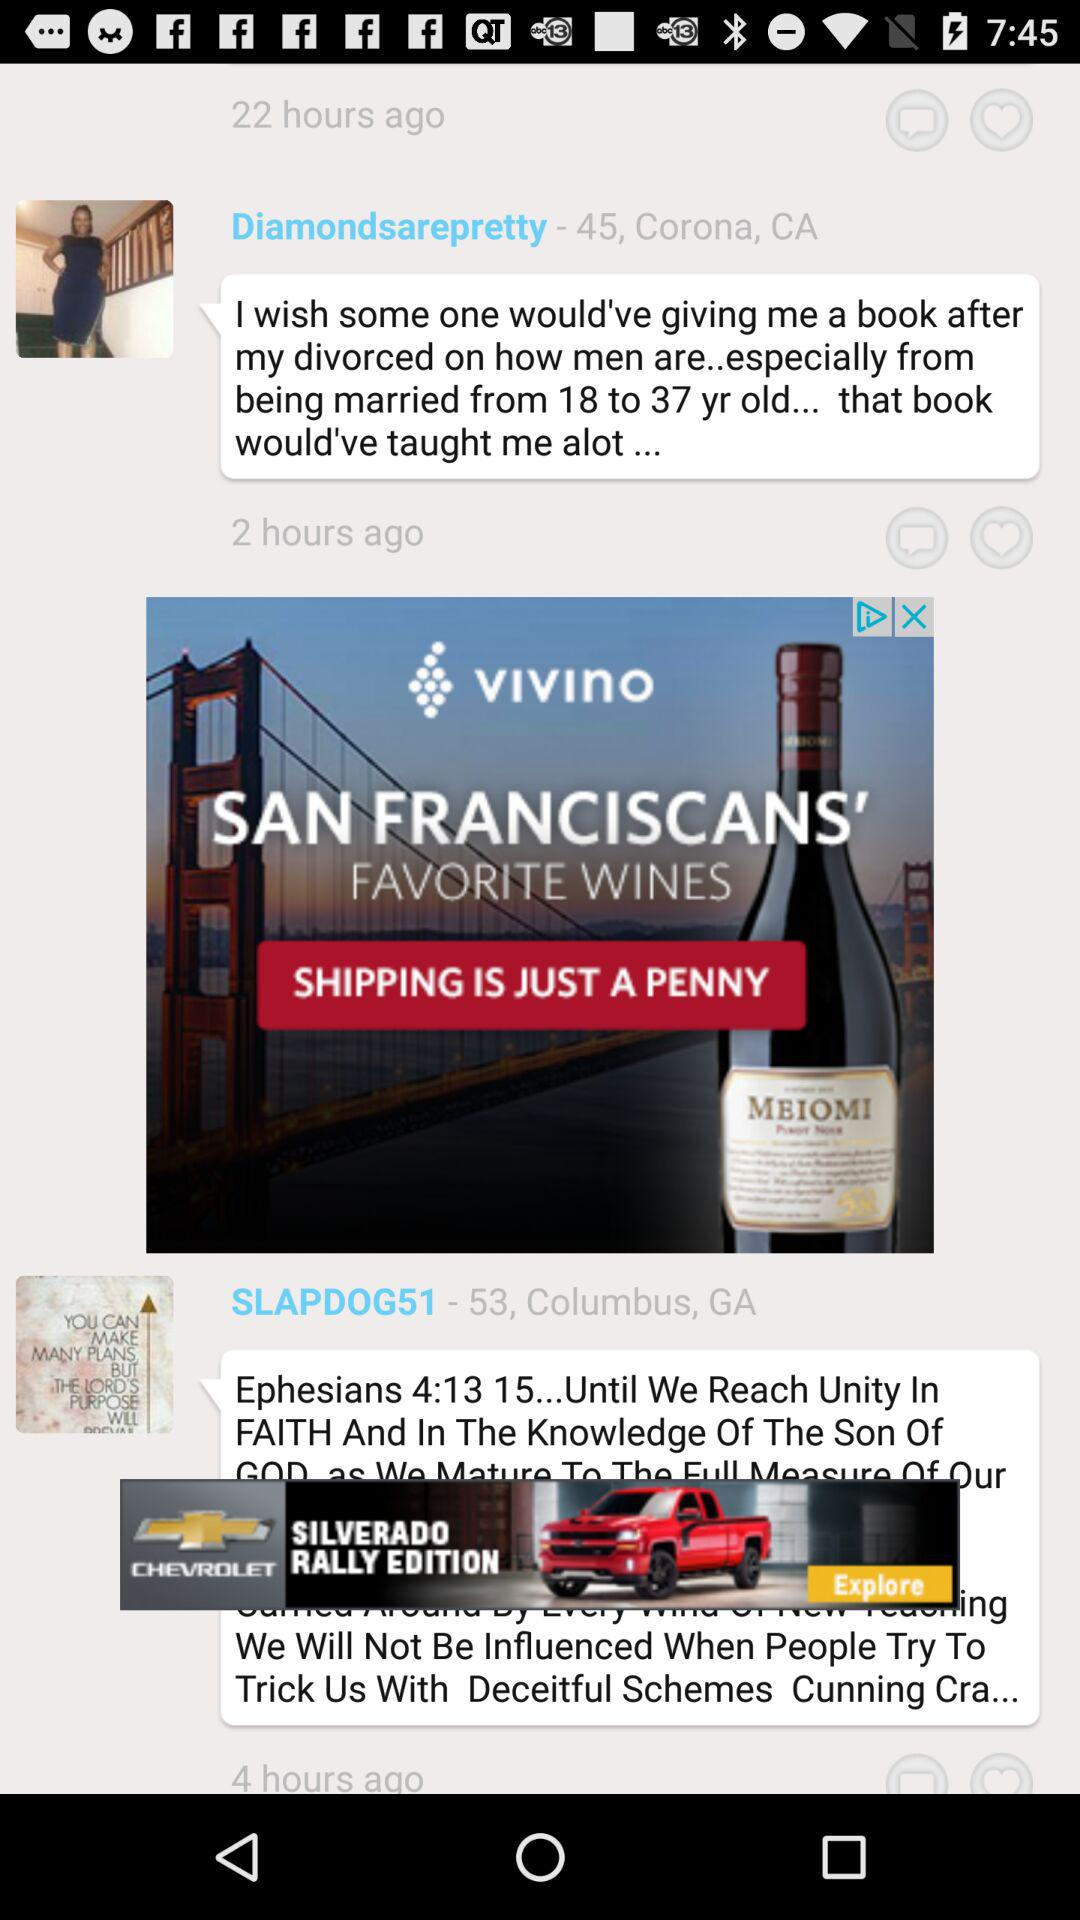Which message was sent 6 hours ago?
When the provided information is insufficient, respond with <no answer>. <no answer> 